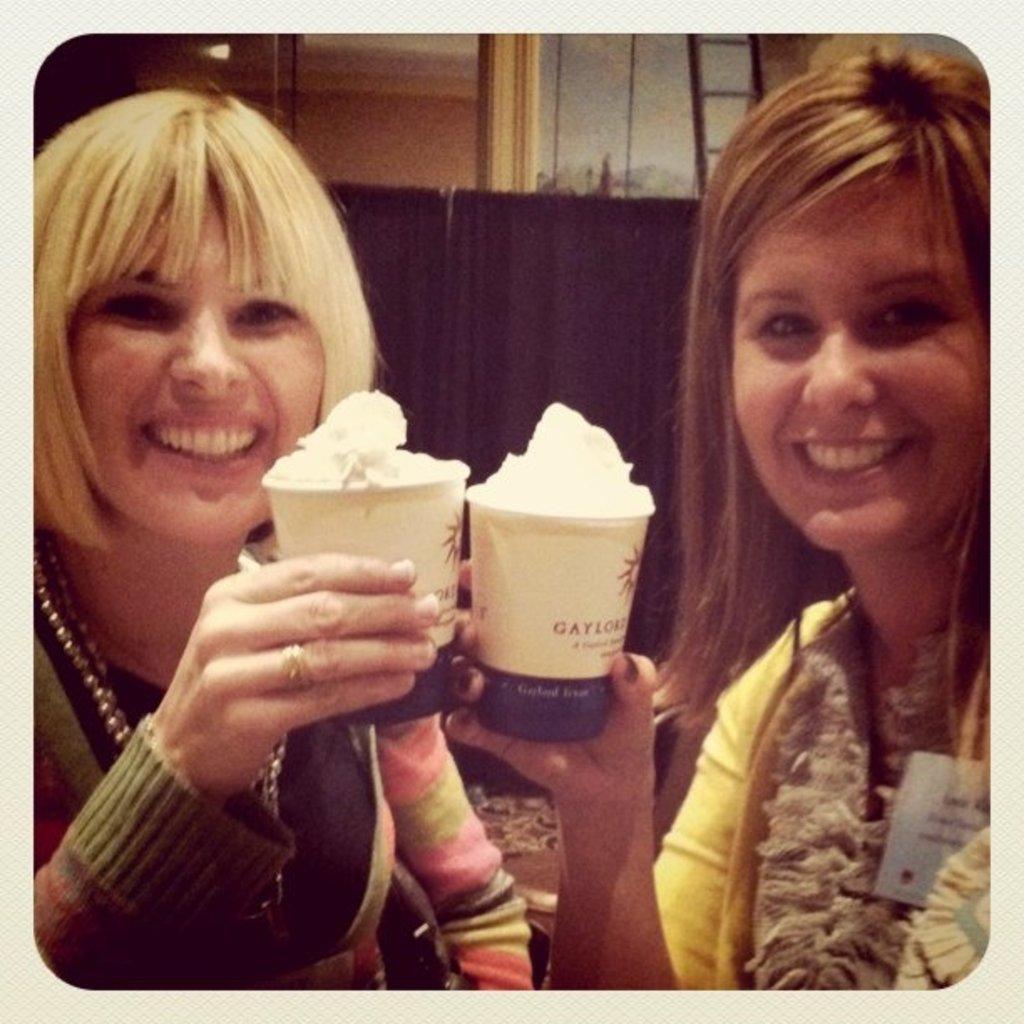Describe this image in one or two sentences. In this image we can see women and cups with a food item. In the background of the image there is a curtain, ladder, wall and other objects. 